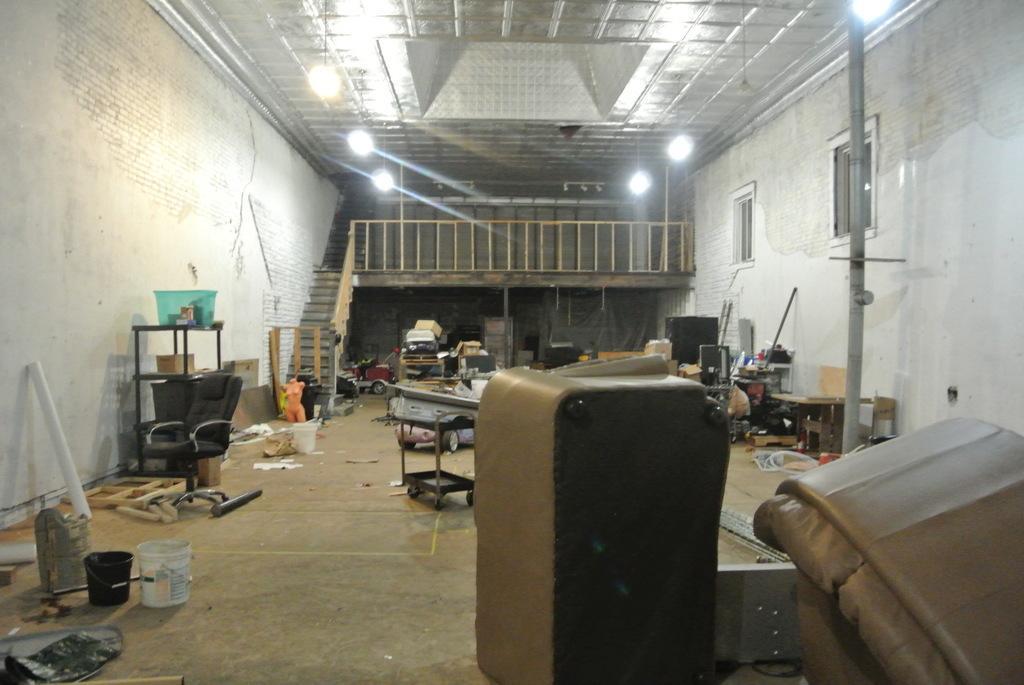How would you summarize this image in a sentence or two? In this image, we can see a chair, some buckets, rods, stands, some repaired sofas, wooden blocks and some other objects on the floor. In the background, we can see lights, stairs, railings, windows and there is a wall and a pole. At the top, there is a roof. 